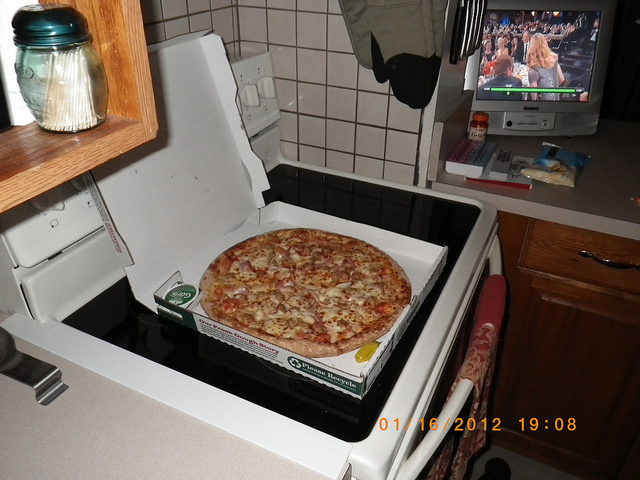Please extract the text content from this image. 1 9 08 2012 16 01 